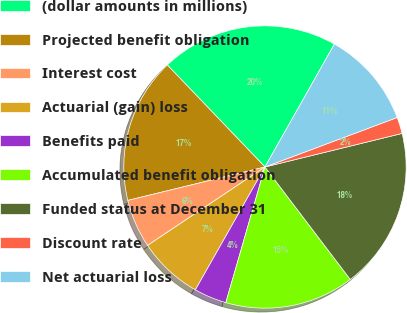<chart> <loc_0><loc_0><loc_500><loc_500><pie_chart><fcel>(dollar amounts in millions)<fcel>Projected benefit obligation<fcel>Interest cost<fcel>Actuarial (gain) loss<fcel>Benefits paid<fcel>Accumulated benefit obligation<fcel>Funded status at December 31<fcel>Discount rate<fcel>Net actuarial loss<nl><fcel>20.34%<fcel>16.65%<fcel>5.57%<fcel>7.42%<fcel>3.73%<fcel>14.8%<fcel>18.49%<fcel>1.88%<fcel>11.11%<nl></chart> 